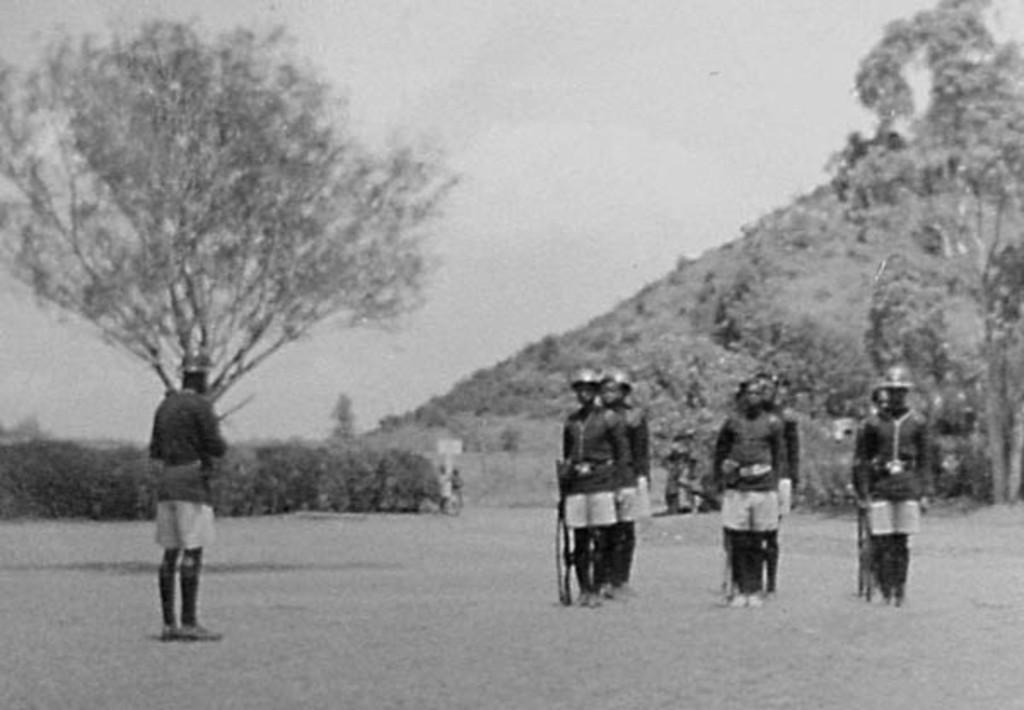What is the color scheme of the image? The image is black and white. What can be seen in the foreground of the image? There is a group of people standing in the image. What type of vegetation is present in the image? There are plants and trees in the image. What geographical feature is visible in the image? There is a hill in the image. What is visible in the background of the image? The sky is visible in the background of the image. What type of rose is being held by the person on the left in the image? There is no rose present in the image; it is a black and white image with no visible flowers. How many muscles can be seen flexing in the image? The image does not show any muscles flexing, as it primarily features a group of people standing and the surrounding environment. 